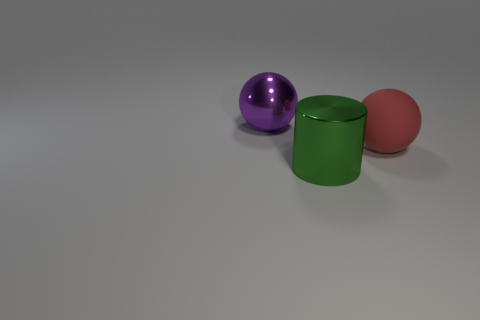What number of cylinders are metallic things or yellow shiny objects?
Provide a short and direct response. 1. What is the material of the large thing right of the large metallic cylinder?
Your answer should be compact. Rubber. What number of objects are red balls or green cylinders?
Keep it short and to the point. 2. What number of other objects are the same shape as the green metal thing?
Offer a terse response. 0. Is the large sphere that is on the left side of the big red matte thing made of the same material as the ball on the right side of the large purple ball?
Give a very brief answer. No. What is the shape of the object that is behind the big green thing and left of the big red rubber sphere?
Your answer should be compact. Sphere. Is there anything else that is the same material as the large red thing?
Ensure brevity in your answer.  No. There is a big object that is to the left of the large red thing and behind the green cylinder; what material is it made of?
Provide a short and direct response. Metal. What is the shape of the large thing that is made of the same material as the large cylinder?
Your answer should be very brief. Sphere. Are there any other things that are the same color as the big cylinder?
Make the answer very short. No. 